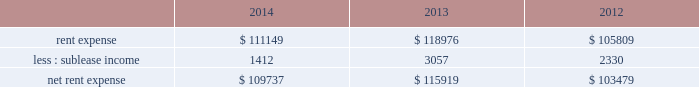Adobe systems incorporated notes to consolidated financial statements ( continued ) note 15 .
Commitments and contingencies lease commitments we lease certain of our facilities and some of our equipment under non-cancellable operating lease arrangements that expire at various dates through 2028 .
We also have one land lease that expires in 2091 .
Rent expense includes base contractual rent and variable costs such as building expenses , utilities , taxes , insurance and equipment rental .
Rent expense and sublease income for these leases for fiscal 2014 , 2013 and 2012 were as follows ( in thousands ) : .
We occupy three office buildings in san jose , california where our corporate headquarters are located .
We reference these office buildings as the almaden tower and the east and west towers .
In august 2014 , we exercised our option to purchase the east and west towers for a total purchase price of $ 143.2 million .
Upon purchase , our investment in the lease receivable of $ 126.8 million was credited against the total purchase price and we were no longer required to maintain a standby letter of credit as stipulated in the east and west towers lease agreement .
We capitalized the east and west towers as property and equipment on our consolidated balance sheets at $ 144.1 million , the lesser of cost or fair value , which represented the total purchase price plus other direct costs associated with the purchase .
See note 6 for discussion of our east and west towers purchase .
The lease agreement for the almaden tower is effective through march 2017 .
We are the investors in the lease receivable related to the almaden tower lease in the amount of $ 80.4 million , which is recorded as investment in lease receivable on our consolidated balance sheets .
As of november 28 , 2014 , the carrying value of the lease receivable related to the almaden tower approximated fair value .
Under the agreement for the almaden tower , we have the option to purchase the building at any time during the lease term for $ 103.6 million .
If we purchase the building , the investment in the lease receivable may be credited against the purchase price .
The residual value guarantee under the almaden tower obligation is $ 89.4 million .
The almaden tower lease is subject to standard covenants including certain financial ratios that are reported to the lessor quarterly .
As of november 28 , 2014 , we were in compliance with all of the covenants .
In the case of a default , the lessor may demand we purchase the building for an amount equal to the lease balance , or require that we remarket or relinquish the building .
If we choose to remarket or are required to do so upon relinquishing the building , we are bound to arrange the sale of the building to an unrelated party and will be required to pay the lessor any shortfall between the net remarketing proceeds and the lease balance , up to the residual value guarantee amount less our investment in lease receivable .
The almaden tower lease qualifies for operating lease accounting treatment and , as such , the building and the related obligation are not included in our consolidated balance sheets .
See note 16 for discussion of our capital lease obligation .
Unconditional purchase obligations our purchase obligations consist of agreements to purchase goods and services entered into in the ordinary course of business. .
For rent expense for fiscal 2014 , 2013 and 2012 , what was the largest rent expense in thousands? 
Computations: table_max(rent expense, none)
Answer: 118976.0. 